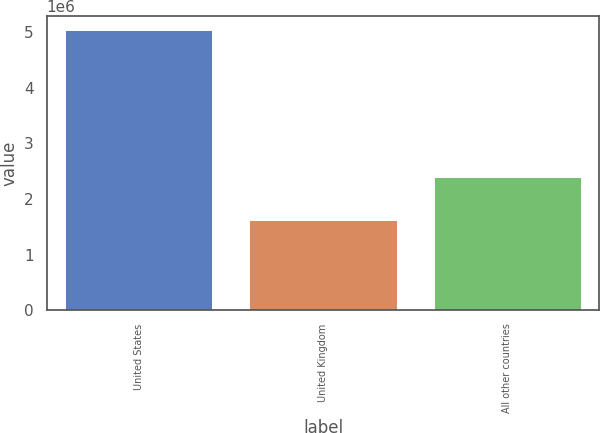<chart> <loc_0><loc_0><loc_500><loc_500><bar_chart><fcel>United States<fcel>United Kingdom<fcel>All other countries<nl><fcel>5.02748e+06<fcel>1.62744e+06<fcel>2.39499e+06<nl></chart> 